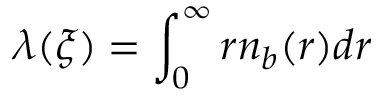Convert formula to latex. <formula><loc_0><loc_0><loc_500><loc_500>\lambda ( \xi ) = \int _ { 0 } ^ { \infty } r n _ { b } ( r ) d r</formula> 